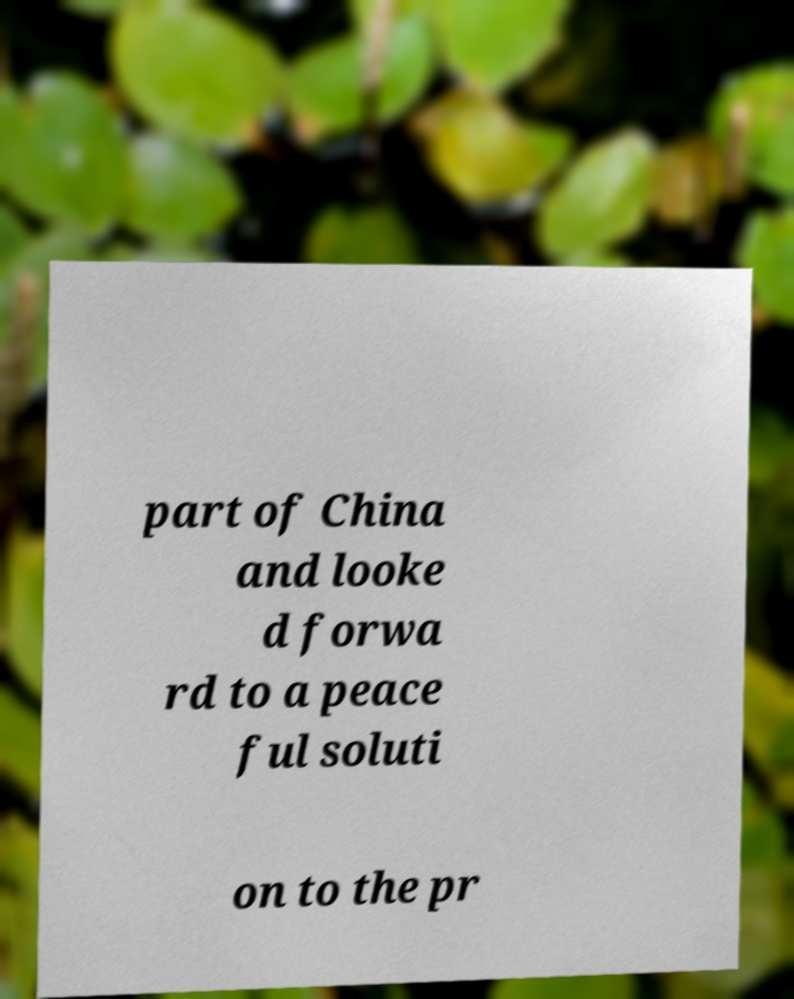Please identify and transcribe the text found in this image. part of China and looke d forwa rd to a peace ful soluti on to the pr 